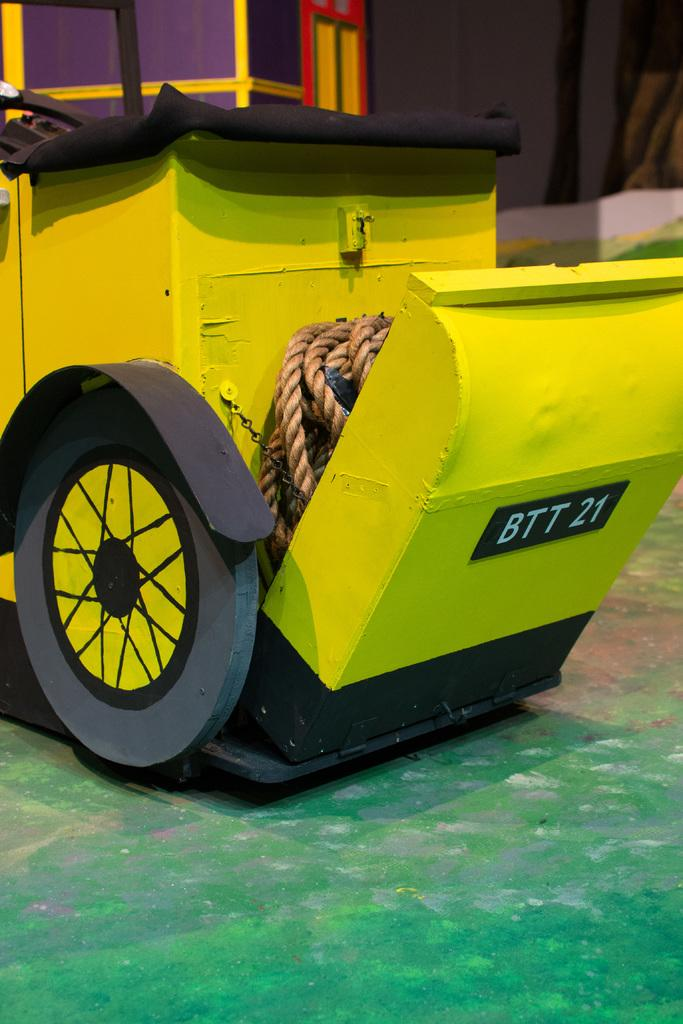What type of material is the object in the image made of? The object in the image is made of metal. What is attached to the metal object? There is a rope attached to the metal object. What can be seen on the floor in the image? There is a wheel on the floor. What is visible in the background of the image? There are objects and a wall visible in the background of the image. What type of mint is growing on the wall in the image? There is no mint growing on the wall in the image; it only features a metal object, a rope, a wheel, and objects and a wall in the background. 